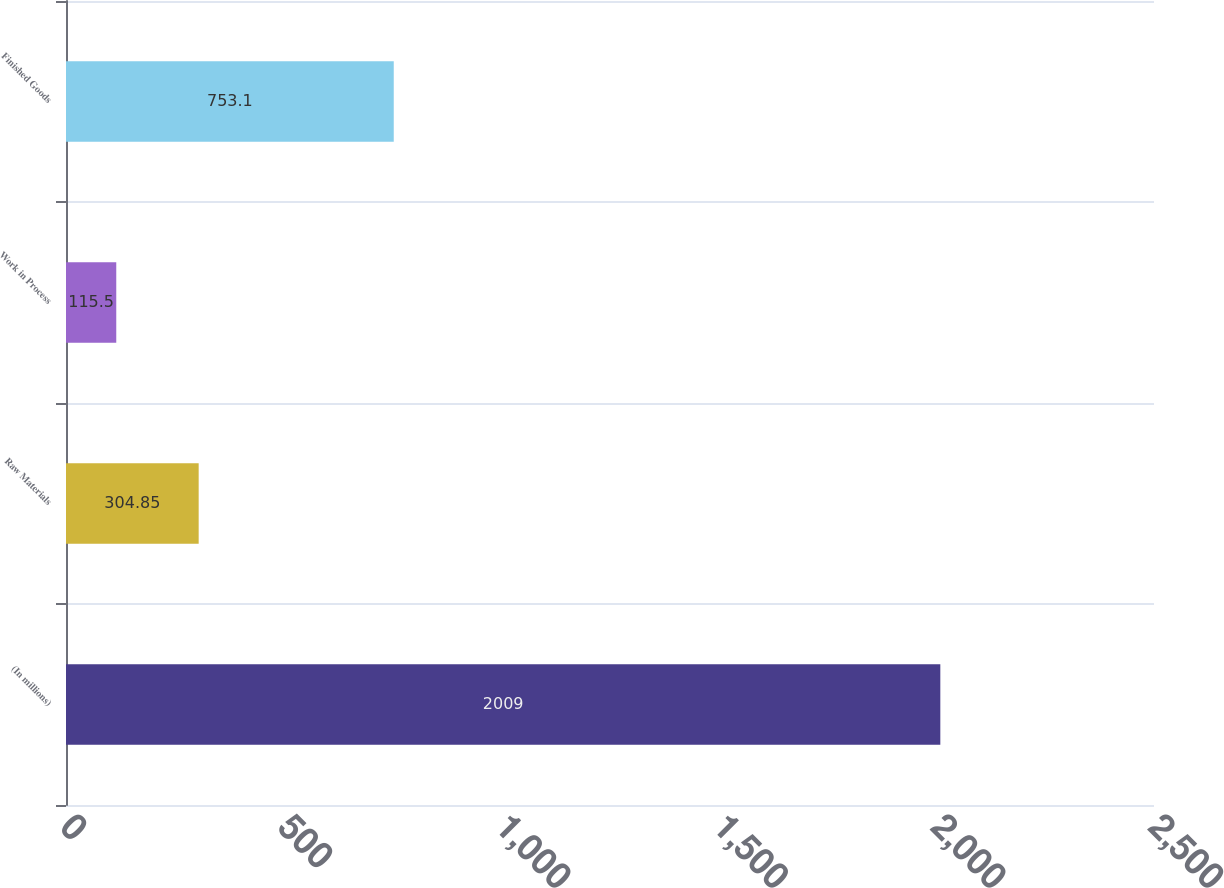<chart> <loc_0><loc_0><loc_500><loc_500><bar_chart><fcel>(In millions)<fcel>Raw Materials<fcel>Work in Process<fcel>Finished Goods<nl><fcel>2009<fcel>304.85<fcel>115.5<fcel>753.1<nl></chart> 